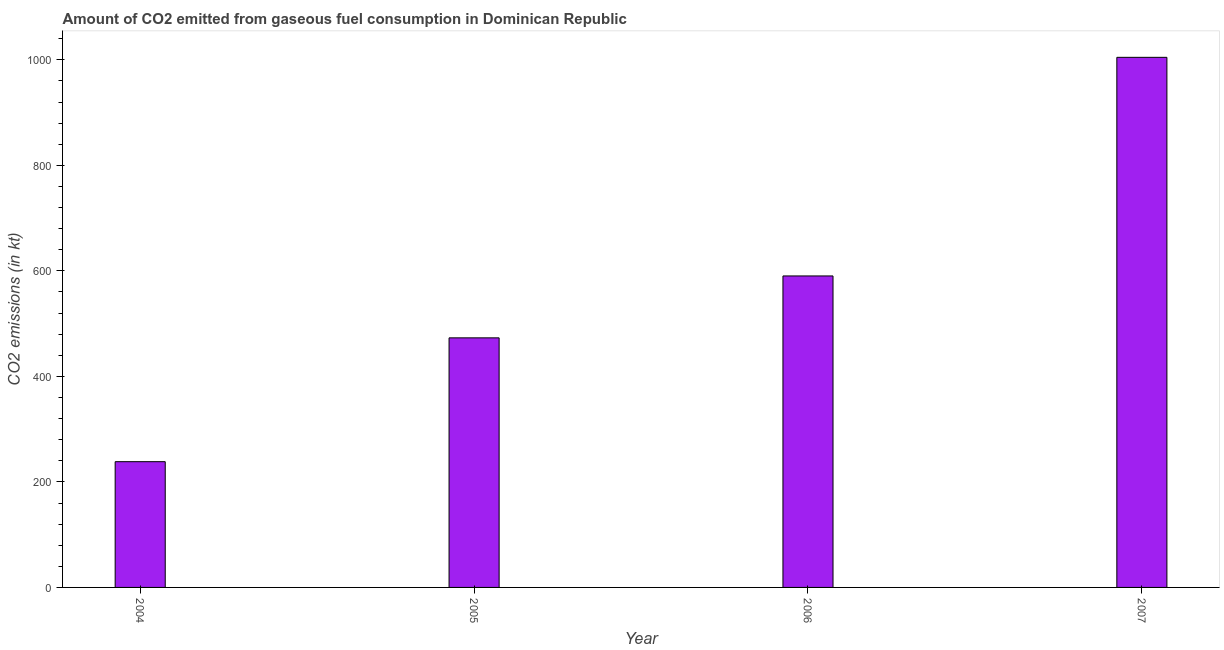Does the graph contain any zero values?
Offer a terse response. No. Does the graph contain grids?
Make the answer very short. No. What is the title of the graph?
Keep it short and to the point. Amount of CO2 emitted from gaseous fuel consumption in Dominican Republic. What is the label or title of the X-axis?
Provide a succinct answer. Year. What is the label or title of the Y-axis?
Give a very brief answer. CO2 emissions (in kt). What is the co2 emissions from gaseous fuel consumption in 2007?
Your answer should be compact. 1004.76. Across all years, what is the maximum co2 emissions from gaseous fuel consumption?
Provide a succinct answer. 1004.76. Across all years, what is the minimum co2 emissions from gaseous fuel consumption?
Your answer should be very brief. 238.35. In which year was the co2 emissions from gaseous fuel consumption maximum?
Offer a terse response. 2007. What is the sum of the co2 emissions from gaseous fuel consumption?
Keep it short and to the point. 2306.54. What is the difference between the co2 emissions from gaseous fuel consumption in 2004 and 2006?
Make the answer very short. -352.03. What is the average co2 emissions from gaseous fuel consumption per year?
Give a very brief answer. 576.64. What is the median co2 emissions from gaseous fuel consumption?
Make the answer very short. 531.71. What is the ratio of the co2 emissions from gaseous fuel consumption in 2004 to that in 2006?
Ensure brevity in your answer.  0.4. What is the difference between the highest and the second highest co2 emissions from gaseous fuel consumption?
Your answer should be very brief. 414.37. Is the sum of the co2 emissions from gaseous fuel consumption in 2005 and 2006 greater than the maximum co2 emissions from gaseous fuel consumption across all years?
Your response must be concise. Yes. What is the difference between the highest and the lowest co2 emissions from gaseous fuel consumption?
Ensure brevity in your answer.  766.4. How many bars are there?
Make the answer very short. 4. Are all the bars in the graph horizontal?
Offer a very short reply. No. How many years are there in the graph?
Your answer should be very brief. 4. What is the difference between two consecutive major ticks on the Y-axis?
Offer a very short reply. 200. Are the values on the major ticks of Y-axis written in scientific E-notation?
Give a very brief answer. No. What is the CO2 emissions (in kt) of 2004?
Keep it short and to the point. 238.35. What is the CO2 emissions (in kt) of 2005?
Your response must be concise. 473.04. What is the CO2 emissions (in kt) of 2006?
Your response must be concise. 590.39. What is the CO2 emissions (in kt) in 2007?
Keep it short and to the point. 1004.76. What is the difference between the CO2 emissions (in kt) in 2004 and 2005?
Provide a succinct answer. -234.69. What is the difference between the CO2 emissions (in kt) in 2004 and 2006?
Your response must be concise. -352.03. What is the difference between the CO2 emissions (in kt) in 2004 and 2007?
Give a very brief answer. -766.4. What is the difference between the CO2 emissions (in kt) in 2005 and 2006?
Your response must be concise. -117.34. What is the difference between the CO2 emissions (in kt) in 2005 and 2007?
Provide a short and direct response. -531.72. What is the difference between the CO2 emissions (in kt) in 2006 and 2007?
Your answer should be very brief. -414.37. What is the ratio of the CO2 emissions (in kt) in 2004 to that in 2005?
Your response must be concise. 0.5. What is the ratio of the CO2 emissions (in kt) in 2004 to that in 2006?
Offer a very short reply. 0.4. What is the ratio of the CO2 emissions (in kt) in 2004 to that in 2007?
Ensure brevity in your answer.  0.24. What is the ratio of the CO2 emissions (in kt) in 2005 to that in 2006?
Provide a succinct answer. 0.8. What is the ratio of the CO2 emissions (in kt) in 2005 to that in 2007?
Your answer should be compact. 0.47. What is the ratio of the CO2 emissions (in kt) in 2006 to that in 2007?
Ensure brevity in your answer.  0.59. 